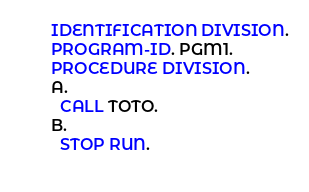<code> <loc_0><loc_0><loc_500><loc_500><_COBOL_>       IDENTIFICATION DIVISION.
       PROGRAM-ID. PGM1.
       PROCEDURE DIVISION.
       A.
         CALL TOTO.
       B.
         STOP RUN.
         
</code> 